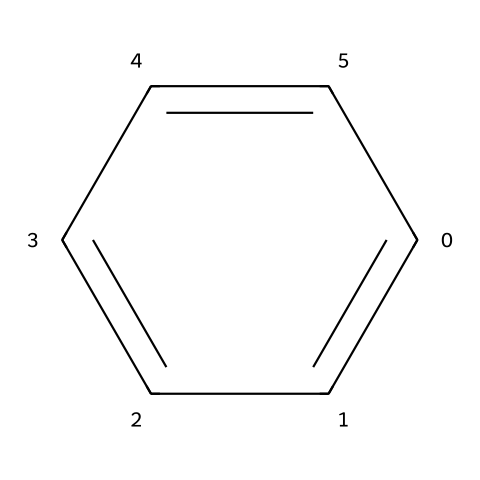What is the name of this chemical? The chemical structure shows a six-membered carbon ring with alternating double bonds, characteristic of benzene, which is a well-known aromatic hydrocarbon.
Answer: benzene How many carbon atoms are present in the structure? The SMILES representation indicates six 'c' atoms, which correspond to six carbon atoms in the benzene molecule.
Answer: 6 What type of bonding is primarily present in this chemical? The structure contains alternating double bonds indicating resonance, which is a hallmark of aromatic compounds like benzene, showing it has both sigma and pi bonds.
Answer: covalent What is the primary health risk associated with benzene exposure? Benzene is known to be a carcinogen, particularly associated with blood-related cancers such as leukemia, due to its ability to cause genetic mutations in stem cells.
Answer: carcinogen How does the molecular structure of benzene influence its volatility? The planarity and no lone pairs of electrons on the carbon atoms allow for effective packing and interactions between molecules, leading to higher volatility as it tends to evaporate easily.
Answer: high What type of intermolecular forces are present in benzene? The primary intermolecular forces in benzene are London dispersion forces, which arise due to temporary dipoles formed during the movement of electrons in the non-polar compound.
Answer: dispersion forces 